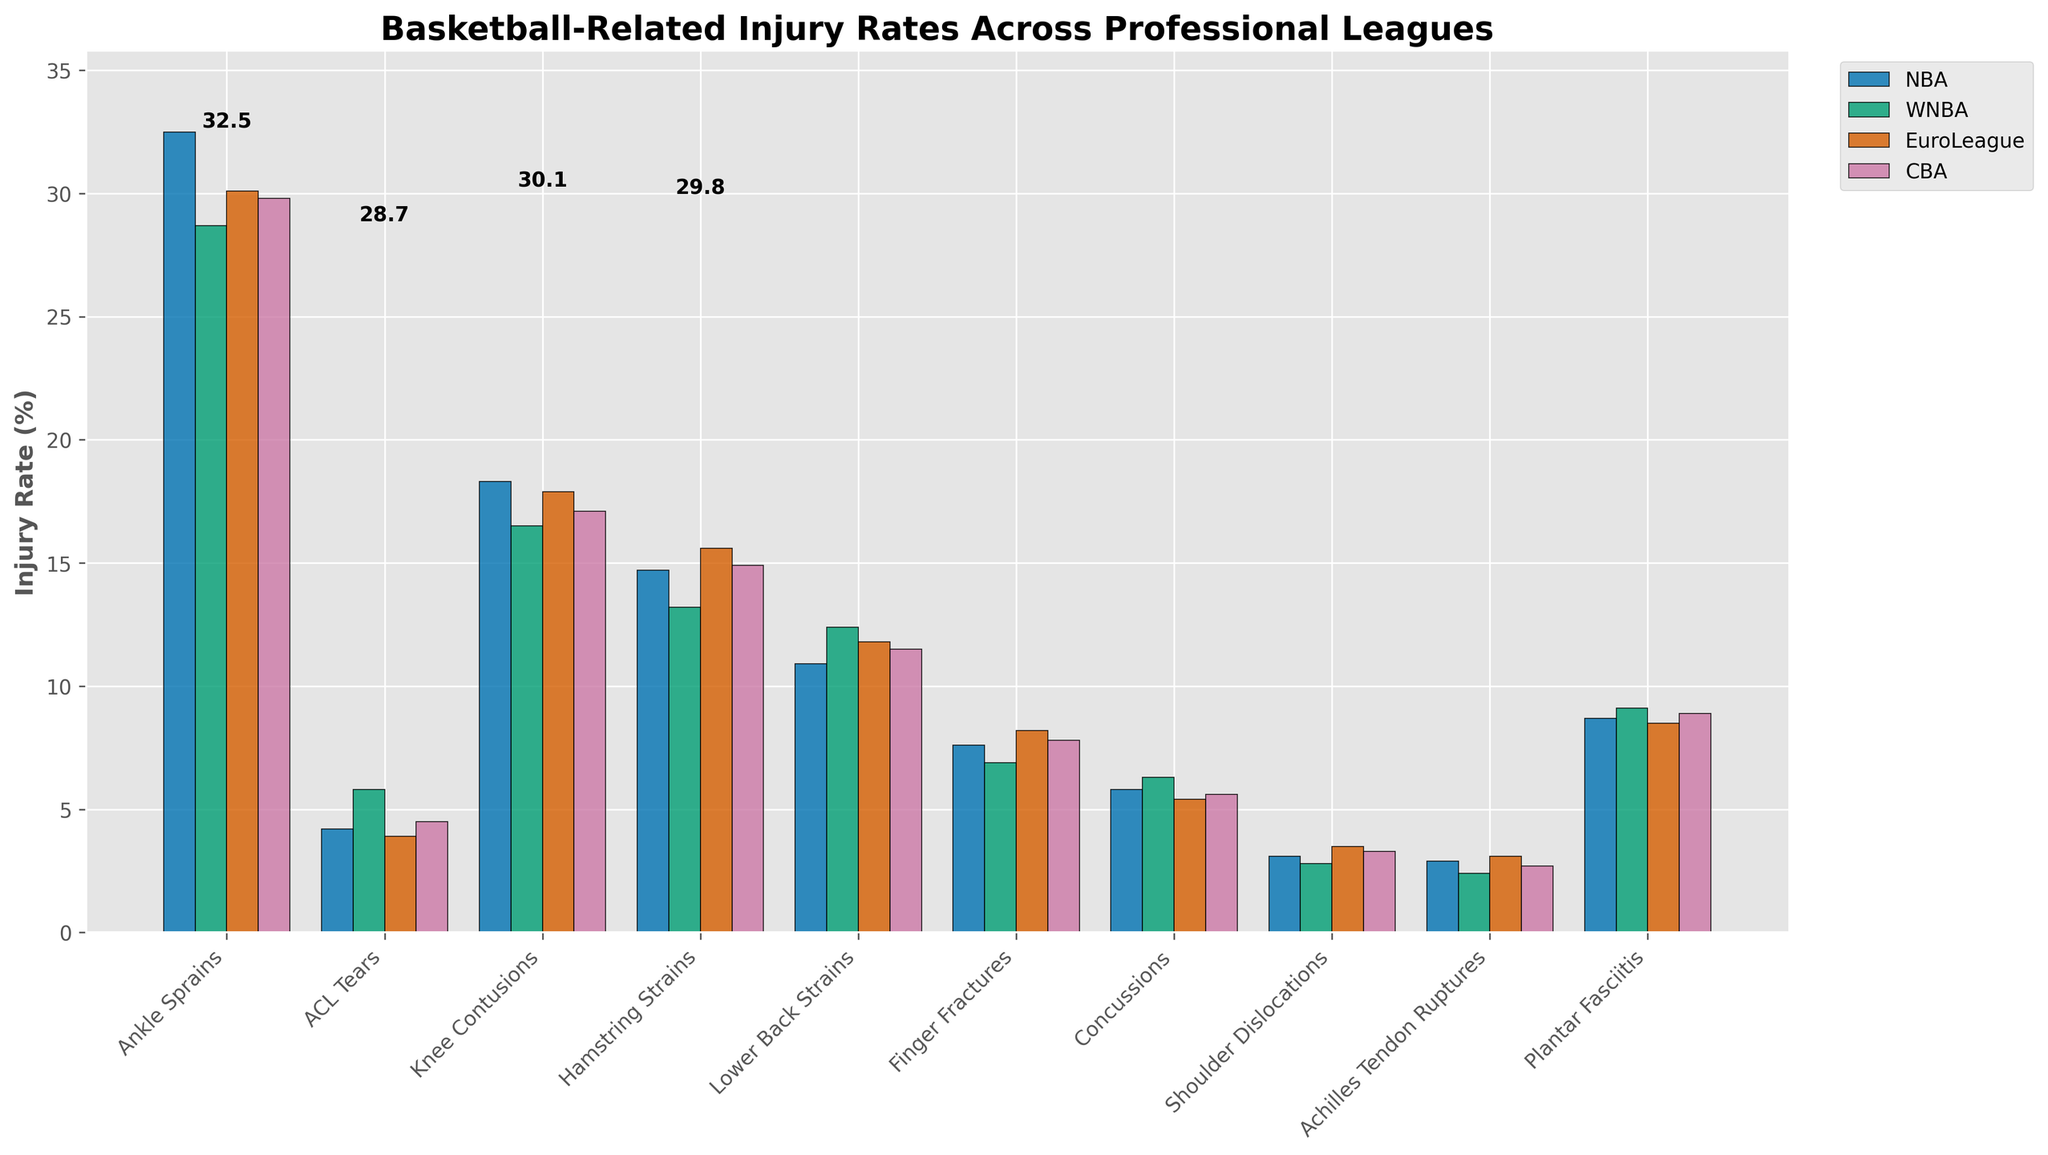Which injury type has the highest injury rate in the NBA? The figure shows four bars grouped by injury type for different leagues. The highest bar in the NBA group corresponds to Ankle Sprains with 32.5%.
Answer: Ankle Sprains What's the difference in the injury rate for Ankle Sprains between the NBA and WNBA? Look at the height of the bars for Ankle Sprains for both the NBA (32.5%) and WNBA (28.7%). Subtract the WNBA value from the NBA value: 32.5% - 28.7% = 3.8%.
Answer: 3.8% Which league has the lowest injury rate for Shoulder Dislocations? Observe the four bars corresponding to Shoulder Dislocations. The WNBA has the shortest bar at 2.8%.
Answer: WNBA Is the injury rate for ACL Tears higher in the NBA or EuroLeague? Compare the height of the bars for ACL Tears in the NBA (4.2%) and EuroLeague (3.9%). The NBA bar is slightly taller.
Answer: NBA What is the average injury rate for Hamstring Strains across all leagues? Add up the injury rates for Hamstring Strains in NBA (14.7%), WNBA (13.2%), EuroLeague (15.6%), and CBA (14.9%). Divide by 4: (14.7 + 13.2 + 15.6 + 14.9)/4 = 14.6%.
Answer: 14.6% Which injury type has the most similar rates across all four leagues? Visually compare the heights of the bars across all injury types for uniformity. Plantar Fasciitis has close values: NBA (8.7%), WNBA (9.1%), EuroLeague (8.5%), CBA (8.9%).
Answer: Plantar Fasciitis How many injury types have higher rates in the EuroLeague compared to the NBA? Compare the height of bars for each injury type between the EuroLeague and NBA. ACL Tears (3.9 vs. 4.2) and Shoulder Dislocations (3.5 vs. 3.1) are lower in EuroLeague. For the rest, EuroLeague either matches or is lower.
Answer: 0 What's the total injury rate for all types combined in the CBA? Sum up all injury rates for each injury type in the CBA: 29.8 + 4.5 + 17.1 + 14.9 + 11.5 + 7.8 + 5.6 + 3.3 + 2.7 + 8.9 = 105.1%.
Answer: 105.1% 